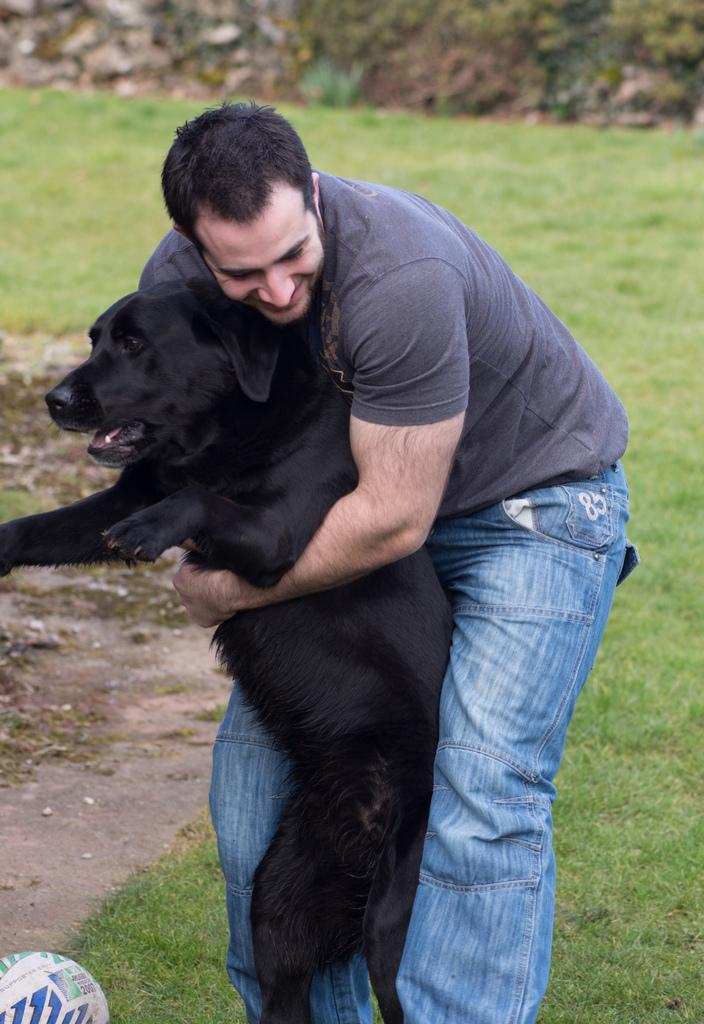What is the main subject of the image? There is a man in the image. What is the man doing in the image? The man is standing on the ground. What is the man holding in the image? The man is holding a black dog. What type of surface is the man standing on? There is grass and mud on the ground. What object can be seen at the bottom of the image? There is a ball at the bottom of the image. How does the man's nerve affect the dust in the image? There is no mention of dust or the man's nerve in the image, so it is not possible to answer this question. 